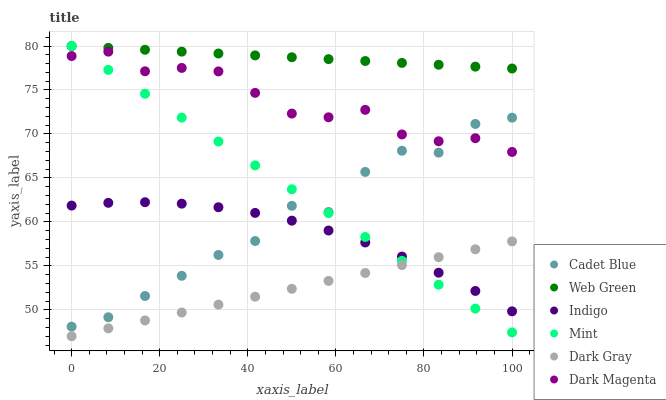Does Dark Gray have the minimum area under the curve?
Answer yes or no. Yes. Does Web Green have the maximum area under the curve?
Answer yes or no. Yes. Does Indigo have the minimum area under the curve?
Answer yes or no. No. Does Indigo have the maximum area under the curve?
Answer yes or no. No. Is Web Green the smoothest?
Answer yes or no. Yes. Is Cadet Blue the roughest?
Answer yes or no. Yes. Is Indigo the smoothest?
Answer yes or no. No. Is Indigo the roughest?
Answer yes or no. No. Does Dark Gray have the lowest value?
Answer yes or no. Yes. Does Indigo have the lowest value?
Answer yes or no. No. Does Mint have the highest value?
Answer yes or no. Yes. Does Indigo have the highest value?
Answer yes or no. No. Is Dark Magenta less than Web Green?
Answer yes or no. Yes. Is Dark Magenta greater than Dark Gray?
Answer yes or no. Yes. Does Indigo intersect Cadet Blue?
Answer yes or no. Yes. Is Indigo less than Cadet Blue?
Answer yes or no. No. Is Indigo greater than Cadet Blue?
Answer yes or no. No. Does Dark Magenta intersect Web Green?
Answer yes or no. No. 